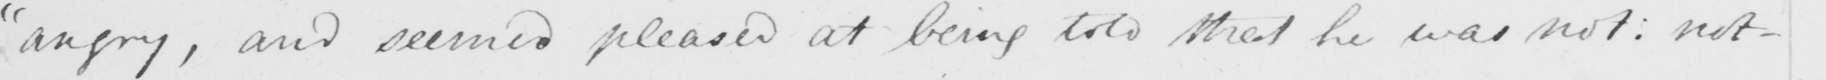What is written in this line of handwriting? angry ,  " and seemed pleased at being told that he was not :  not- 